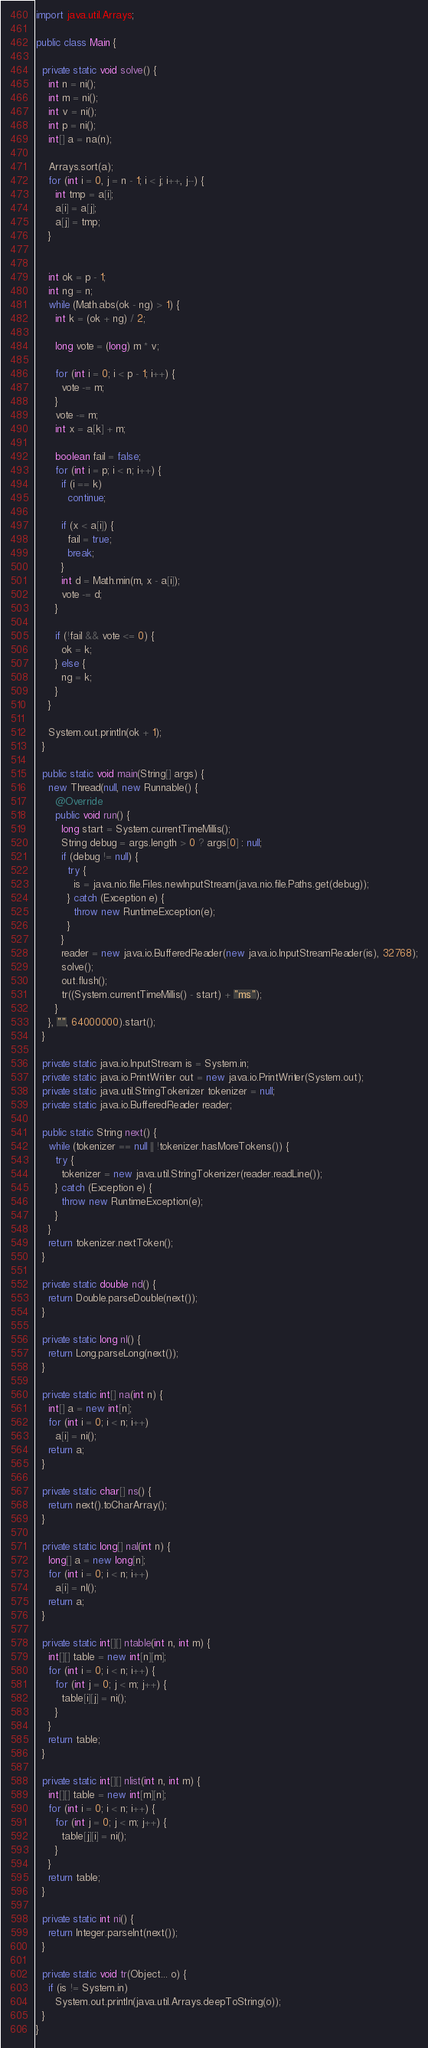<code> <loc_0><loc_0><loc_500><loc_500><_Java_>
import java.util.Arrays;

public class Main {

  private static void solve() {
    int n = ni();
    int m = ni();
    int v = ni();
    int p = ni();
    int[] a = na(n);

    Arrays.sort(a);
    for (int i = 0, j = n - 1; i < j; i++, j--) {
      int tmp = a[i];
      a[i] = a[j];
      a[j] = tmp;
    }


    int ok = p - 1;
    int ng = n;
    while (Math.abs(ok - ng) > 1) {
      int k = (ok + ng) / 2;

      long vote = (long) m * v;

      for (int i = 0; i < p - 1; i++) {
        vote -= m;
      }
      vote -= m;
      int x = a[k] + m;

      boolean fail = false;
      for (int i = p; i < n; i++) {
        if (i == k)
          continue;

        if (x < a[i]) {
          fail = true;
          break;
        }
        int d = Math.min(m, x - a[i]);
        vote -= d;
      }

      if (!fail && vote <= 0) {
        ok = k;
      } else {
        ng = k;
      }
    }

    System.out.println(ok + 1);
  }

  public static void main(String[] args) {
    new Thread(null, new Runnable() {
      @Override
      public void run() {
        long start = System.currentTimeMillis();
        String debug = args.length > 0 ? args[0] : null;
        if (debug != null) {
          try {
            is = java.nio.file.Files.newInputStream(java.nio.file.Paths.get(debug));
          } catch (Exception e) {
            throw new RuntimeException(e);
          }
        }
        reader = new java.io.BufferedReader(new java.io.InputStreamReader(is), 32768);
        solve();
        out.flush();
        tr((System.currentTimeMillis() - start) + "ms");
      }
    }, "", 64000000).start();
  }

  private static java.io.InputStream is = System.in;
  private static java.io.PrintWriter out = new java.io.PrintWriter(System.out);
  private static java.util.StringTokenizer tokenizer = null;
  private static java.io.BufferedReader reader;

  public static String next() {
    while (tokenizer == null || !tokenizer.hasMoreTokens()) {
      try {
        tokenizer = new java.util.StringTokenizer(reader.readLine());
      } catch (Exception e) {
        throw new RuntimeException(e);
      }
    }
    return tokenizer.nextToken();
  }

  private static double nd() {
    return Double.parseDouble(next());
  }

  private static long nl() {
    return Long.parseLong(next());
  }

  private static int[] na(int n) {
    int[] a = new int[n];
    for (int i = 0; i < n; i++)
      a[i] = ni();
    return a;
  }

  private static char[] ns() {
    return next().toCharArray();
  }

  private static long[] nal(int n) {
    long[] a = new long[n];
    for (int i = 0; i < n; i++)
      a[i] = nl();
    return a;
  }

  private static int[][] ntable(int n, int m) {
    int[][] table = new int[n][m];
    for (int i = 0; i < n; i++) {
      for (int j = 0; j < m; j++) {
        table[i][j] = ni();
      }
    }
    return table;
  }

  private static int[][] nlist(int n, int m) {
    int[][] table = new int[m][n];
    for (int i = 0; i < n; i++) {
      for (int j = 0; j < m; j++) {
        table[j][i] = ni();
      }
    }
    return table;
  }

  private static int ni() {
    return Integer.parseInt(next());
  }

  private static void tr(Object... o) {
    if (is != System.in)
      System.out.println(java.util.Arrays.deepToString(o));
  }
}

</code> 